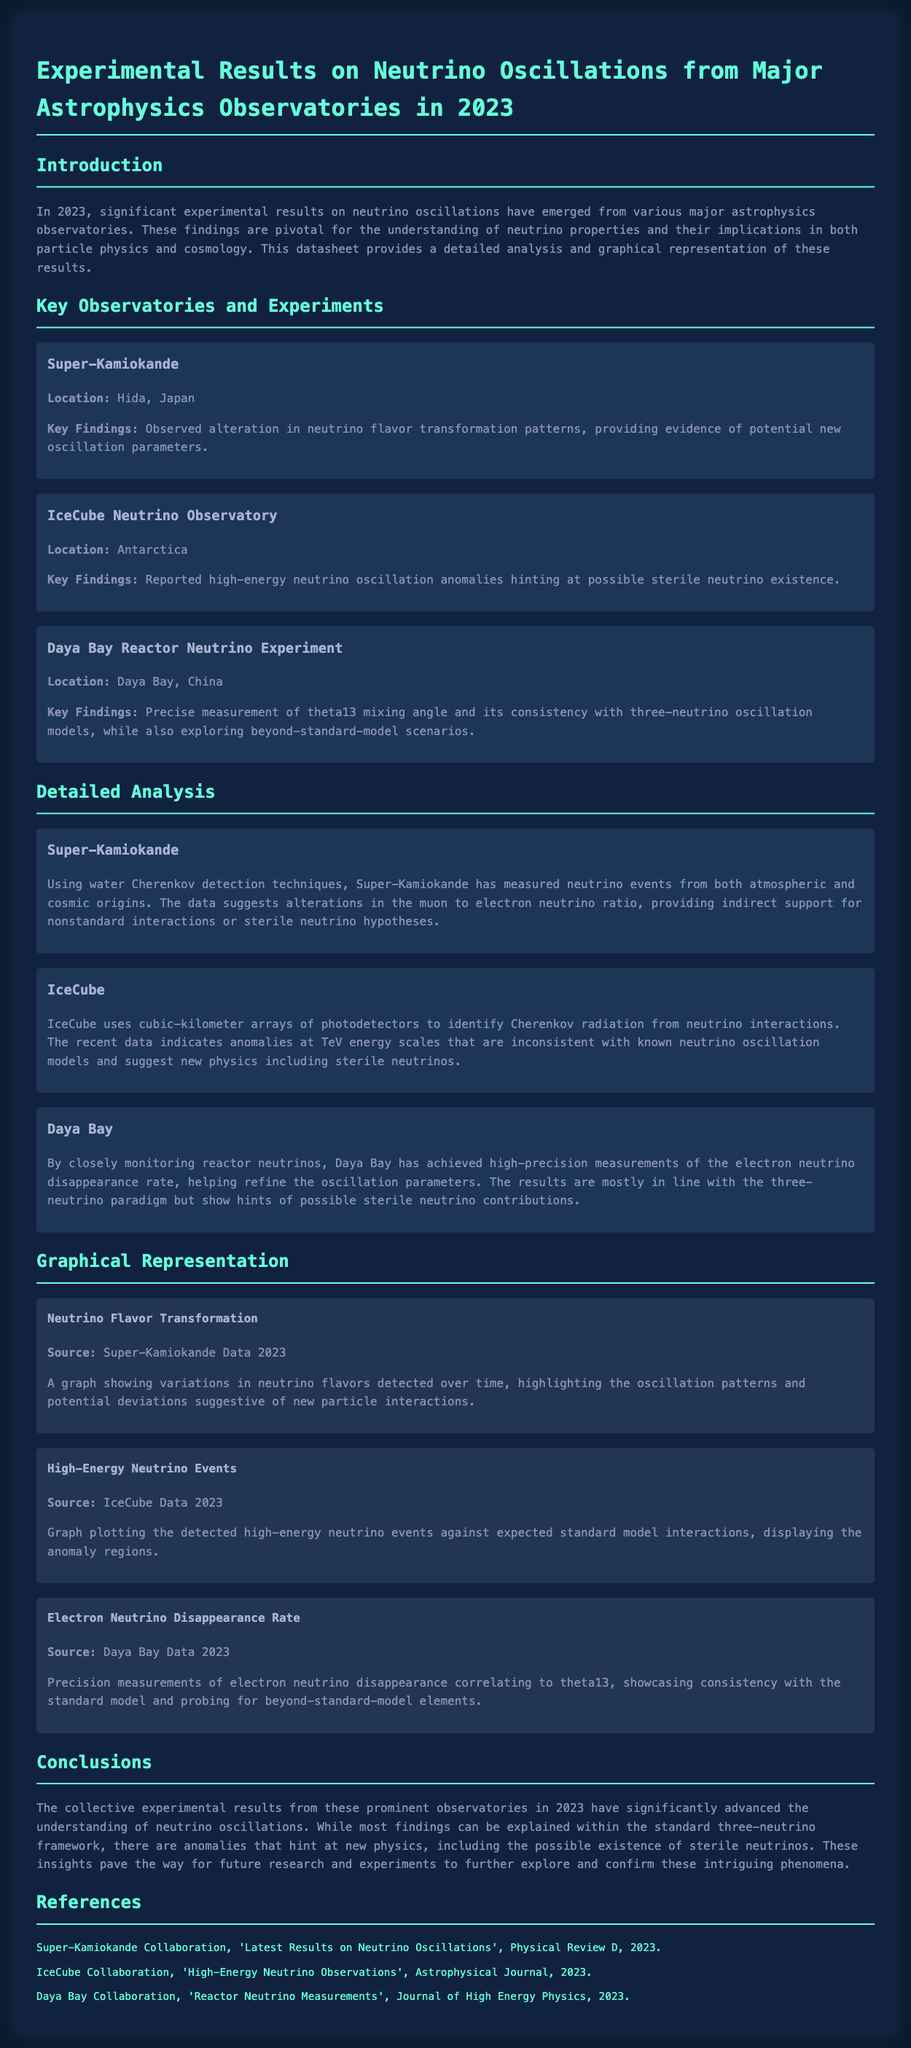What are the key findings from the IceCube Neutrino Observatory? The key findings include high-energy neutrino oscillation anomalies hinting at possible sterile neutrino existence.
Answer: High-energy neutrino oscillation anomalies hinting at possible sterile neutrino existence What technique did Super-Kamiokande use for detection? Super-Kamiokande employed water Cherenkov detection techniques for measuring neutrino events.
Answer: Water Cherenkov detection techniques What is the location of the Daya Bay Reactor Neutrino Experiment? Daya Bay Reactor Neutrino Experiment is located in Daya Bay, China.
Answer: Daya Bay, China What does the graph titled "Neutrino Flavor Transformation" illustrate? The graph illustrates variations in neutrino flavors detected over time, highlighting oscillation patterns and potential deviations.
Answer: Variations in neutrino flavors detected over time Which observatory reported anomalies at TeV energy scales? The IceCube Neutrino Observatory reported anomalies at TeV energy scales indicating new physics.
Answer: IceCube Neutrino Observatory What do the results from Daya Bay mainly support? The results from Daya Bay are mostly in line with the three-neutrino paradigm.
Answer: Three-neutrino paradigm What is the significance of the 2023 findings on neutrino oscillations? The findings hint at new physics, including possible existence of sterile neutrinos.
Answer: New physics, including possible existence of sterile neutrinos How is the data from IceCube represented? The data from IceCube is represented as a graph plotting detected high-energy neutrino events against expected standard model interactions.
Answer: Graph plotting detected high-energy neutrino events 